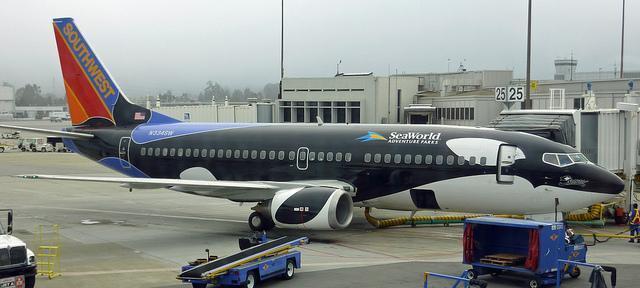How many trucks are in the picture?
Give a very brief answer. 2. 